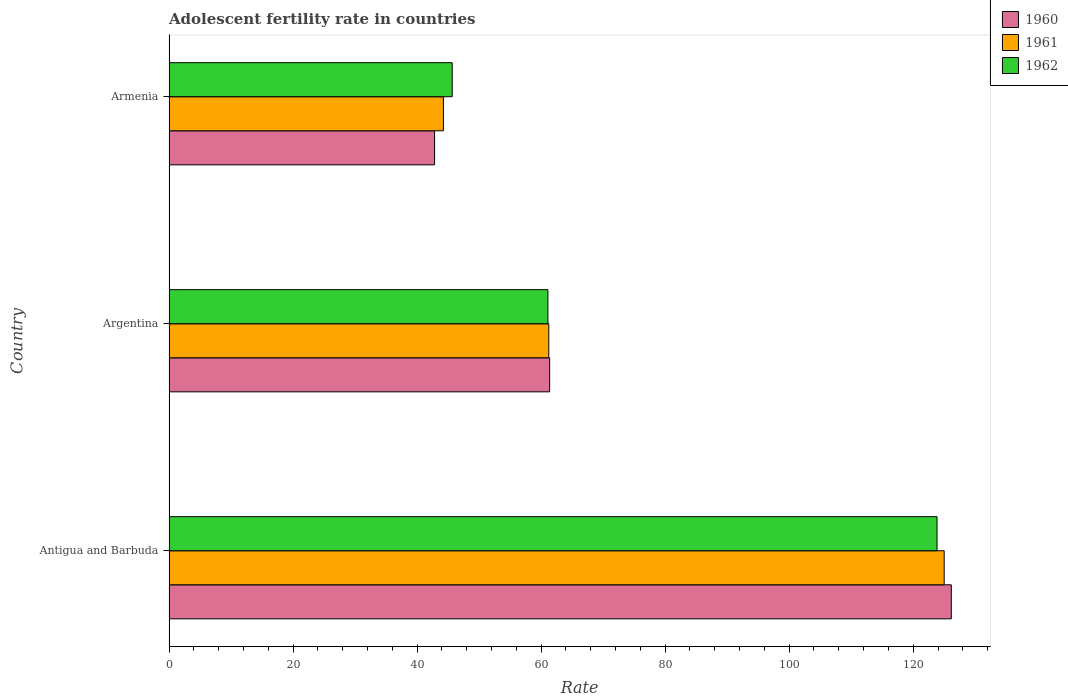How many groups of bars are there?
Keep it short and to the point. 3. Are the number of bars per tick equal to the number of legend labels?
Give a very brief answer. Yes. What is the label of the 3rd group of bars from the top?
Provide a short and direct response. Antigua and Barbuda. What is the adolescent fertility rate in 1961 in Armenia?
Offer a terse response. 44.24. Across all countries, what is the maximum adolescent fertility rate in 1960?
Give a very brief answer. 126.14. Across all countries, what is the minimum adolescent fertility rate in 1962?
Give a very brief answer. 45.66. In which country was the adolescent fertility rate in 1962 maximum?
Your response must be concise. Antigua and Barbuda. In which country was the adolescent fertility rate in 1962 minimum?
Give a very brief answer. Armenia. What is the total adolescent fertility rate in 1960 in the graph?
Offer a very short reply. 230.35. What is the difference between the adolescent fertility rate in 1961 in Argentina and that in Armenia?
Keep it short and to the point. 16.99. What is the difference between the adolescent fertility rate in 1961 in Argentina and the adolescent fertility rate in 1962 in Antigua and Barbuda?
Make the answer very short. -62.6. What is the average adolescent fertility rate in 1961 per country?
Make the answer very short. 76.82. What is the difference between the adolescent fertility rate in 1962 and adolescent fertility rate in 1961 in Argentina?
Your response must be concise. -0.14. What is the ratio of the adolescent fertility rate in 1961 in Antigua and Barbuda to that in Armenia?
Your response must be concise. 2.83. Is the adolescent fertility rate in 1962 in Antigua and Barbuda less than that in Armenia?
Make the answer very short. No. Is the difference between the adolescent fertility rate in 1962 in Argentina and Armenia greater than the difference between the adolescent fertility rate in 1961 in Argentina and Armenia?
Give a very brief answer. No. What is the difference between the highest and the second highest adolescent fertility rate in 1962?
Provide a short and direct response. 62.74. What is the difference between the highest and the lowest adolescent fertility rate in 1961?
Provide a succinct answer. 80.75. What does the 1st bar from the bottom in Armenia represents?
Provide a short and direct response. 1960. How many bars are there?
Provide a succinct answer. 9. What is the difference between two consecutive major ticks on the X-axis?
Offer a terse response. 20. Are the values on the major ticks of X-axis written in scientific E-notation?
Your answer should be compact. No. Where does the legend appear in the graph?
Ensure brevity in your answer.  Top right. How are the legend labels stacked?
Offer a terse response. Vertical. What is the title of the graph?
Offer a terse response. Adolescent fertility rate in countries. Does "1984" appear as one of the legend labels in the graph?
Offer a terse response. No. What is the label or title of the X-axis?
Keep it short and to the point. Rate. What is the label or title of the Y-axis?
Keep it short and to the point. Country. What is the Rate in 1960 in Antigua and Barbuda?
Your answer should be compact. 126.14. What is the Rate in 1961 in Antigua and Barbuda?
Provide a short and direct response. 124.99. What is the Rate of 1962 in Antigua and Barbuda?
Provide a short and direct response. 123.84. What is the Rate of 1960 in Argentina?
Your answer should be compact. 61.38. What is the Rate of 1961 in Argentina?
Make the answer very short. 61.24. What is the Rate in 1962 in Argentina?
Provide a succinct answer. 61.1. What is the Rate of 1960 in Armenia?
Keep it short and to the point. 42.82. What is the Rate of 1961 in Armenia?
Give a very brief answer. 44.24. What is the Rate in 1962 in Armenia?
Keep it short and to the point. 45.66. Across all countries, what is the maximum Rate of 1960?
Keep it short and to the point. 126.14. Across all countries, what is the maximum Rate of 1961?
Your answer should be compact. 124.99. Across all countries, what is the maximum Rate of 1962?
Offer a terse response. 123.84. Across all countries, what is the minimum Rate of 1960?
Your answer should be very brief. 42.82. Across all countries, what is the minimum Rate in 1961?
Your response must be concise. 44.24. Across all countries, what is the minimum Rate in 1962?
Keep it short and to the point. 45.66. What is the total Rate in 1960 in the graph?
Provide a short and direct response. 230.35. What is the total Rate of 1961 in the graph?
Offer a very short reply. 230.47. What is the total Rate in 1962 in the graph?
Keep it short and to the point. 230.6. What is the difference between the Rate of 1960 in Antigua and Barbuda and that in Argentina?
Provide a succinct answer. 64.77. What is the difference between the Rate in 1961 in Antigua and Barbuda and that in Argentina?
Give a very brief answer. 63.75. What is the difference between the Rate of 1962 in Antigua and Barbuda and that in Argentina?
Your response must be concise. 62.74. What is the difference between the Rate in 1960 in Antigua and Barbuda and that in Armenia?
Provide a succinct answer. 83.32. What is the difference between the Rate in 1961 in Antigua and Barbuda and that in Armenia?
Offer a terse response. 80.75. What is the difference between the Rate in 1962 in Antigua and Barbuda and that in Armenia?
Make the answer very short. 78.18. What is the difference between the Rate in 1960 in Argentina and that in Armenia?
Keep it short and to the point. 18.55. What is the difference between the Rate in 1961 in Argentina and that in Armenia?
Keep it short and to the point. 16.99. What is the difference between the Rate of 1962 in Argentina and that in Armenia?
Ensure brevity in your answer.  15.44. What is the difference between the Rate of 1960 in Antigua and Barbuda and the Rate of 1961 in Argentina?
Your answer should be compact. 64.91. What is the difference between the Rate of 1960 in Antigua and Barbuda and the Rate of 1962 in Argentina?
Make the answer very short. 65.05. What is the difference between the Rate in 1961 in Antigua and Barbuda and the Rate in 1962 in Argentina?
Make the answer very short. 63.89. What is the difference between the Rate in 1960 in Antigua and Barbuda and the Rate in 1961 in Armenia?
Provide a succinct answer. 81.9. What is the difference between the Rate of 1960 in Antigua and Barbuda and the Rate of 1962 in Armenia?
Provide a succinct answer. 80.48. What is the difference between the Rate of 1961 in Antigua and Barbuda and the Rate of 1962 in Armenia?
Offer a terse response. 79.33. What is the difference between the Rate of 1960 in Argentina and the Rate of 1961 in Armenia?
Give a very brief answer. 17.13. What is the difference between the Rate in 1960 in Argentina and the Rate in 1962 in Armenia?
Offer a very short reply. 15.72. What is the difference between the Rate in 1961 in Argentina and the Rate in 1962 in Armenia?
Keep it short and to the point. 15.58. What is the average Rate of 1960 per country?
Your answer should be compact. 76.78. What is the average Rate of 1961 per country?
Your answer should be compact. 76.82. What is the average Rate of 1962 per country?
Offer a terse response. 76.87. What is the difference between the Rate in 1960 and Rate in 1961 in Antigua and Barbuda?
Make the answer very short. 1.15. What is the difference between the Rate of 1960 and Rate of 1962 in Antigua and Barbuda?
Offer a very short reply. 2.3. What is the difference between the Rate of 1961 and Rate of 1962 in Antigua and Barbuda?
Your answer should be very brief. 1.15. What is the difference between the Rate of 1960 and Rate of 1961 in Argentina?
Offer a terse response. 0.14. What is the difference between the Rate in 1960 and Rate in 1962 in Argentina?
Keep it short and to the point. 0.28. What is the difference between the Rate of 1961 and Rate of 1962 in Argentina?
Your response must be concise. 0.14. What is the difference between the Rate of 1960 and Rate of 1961 in Armenia?
Ensure brevity in your answer.  -1.42. What is the difference between the Rate in 1960 and Rate in 1962 in Armenia?
Your answer should be compact. -2.84. What is the difference between the Rate of 1961 and Rate of 1962 in Armenia?
Your answer should be compact. -1.42. What is the ratio of the Rate of 1960 in Antigua and Barbuda to that in Argentina?
Make the answer very short. 2.06. What is the ratio of the Rate of 1961 in Antigua and Barbuda to that in Argentina?
Your answer should be compact. 2.04. What is the ratio of the Rate of 1962 in Antigua and Barbuda to that in Argentina?
Ensure brevity in your answer.  2.03. What is the ratio of the Rate of 1960 in Antigua and Barbuda to that in Armenia?
Your answer should be compact. 2.95. What is the ratio of the Rate in 1961 in Antigua and Barbuda to that in Armenia?
Your response must be concise. 2.83. What is the ratio of the Rate of 1962 in Antigua and Barbuda to that in Armenia?
Keep it short and to the point. 2.71. What is the ratio of the Rate in 1960 in Argentina to that in Armenia?
Your response must be concise. 1.43. What is the ratio of the Rate of 1961 in Argentina to that in Armenia?
Make the answer very short. 1.38. What is the ratio of the Rate of 1962 in Argentina to that in Armenia?
Your answer should be very brief. 1.34. What is the difference between the highest and the second highest Rate of 1960?
Provide a succinct answer. 64.77. What is the difference between the highest and the second highest Rate of 1961?
Provide a succinct answer. 63.75. What is the difference between the highest and the second highest Rate in 1962?
Keep it short and to the point. 62.74. What is the difference between the highest and the lowest Rate in 1960?
Provide a short and direct response. 83.32. What is the difference between the highest and the lowest Rate in 1961?
Your response must be concise. 80.75. What is the difference between the highest and the lowest Rate in 1962?
Make the answer very short. 78.18. 